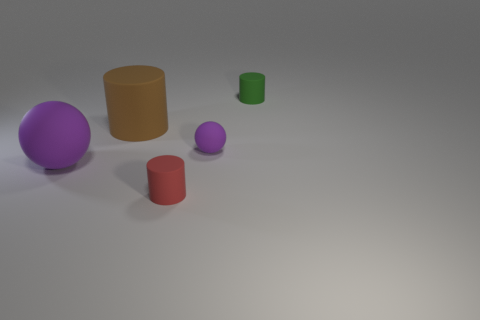Subtract all small cylinders. How many cylinders are left? 1 Add 1 brown rubber things. How many objects exist? 6 Subtract all balls. How many objects are left? 3 Subtract 0 green spheres. How many objects are left? 5 Subtract all large green rubber things. Subtract all red cylinders. How many objects are left? 4 Add 2 red objects. How many red objects are left? 3 Add 3 yellow blocks. How many yellow blocks exist? 3 